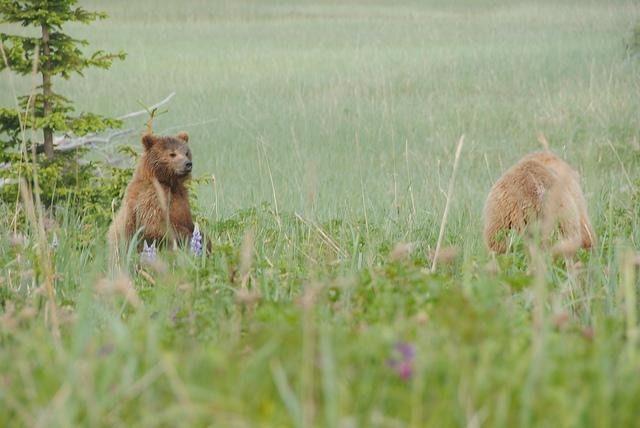How many bears are there?
Give a very brief answer. 2. 